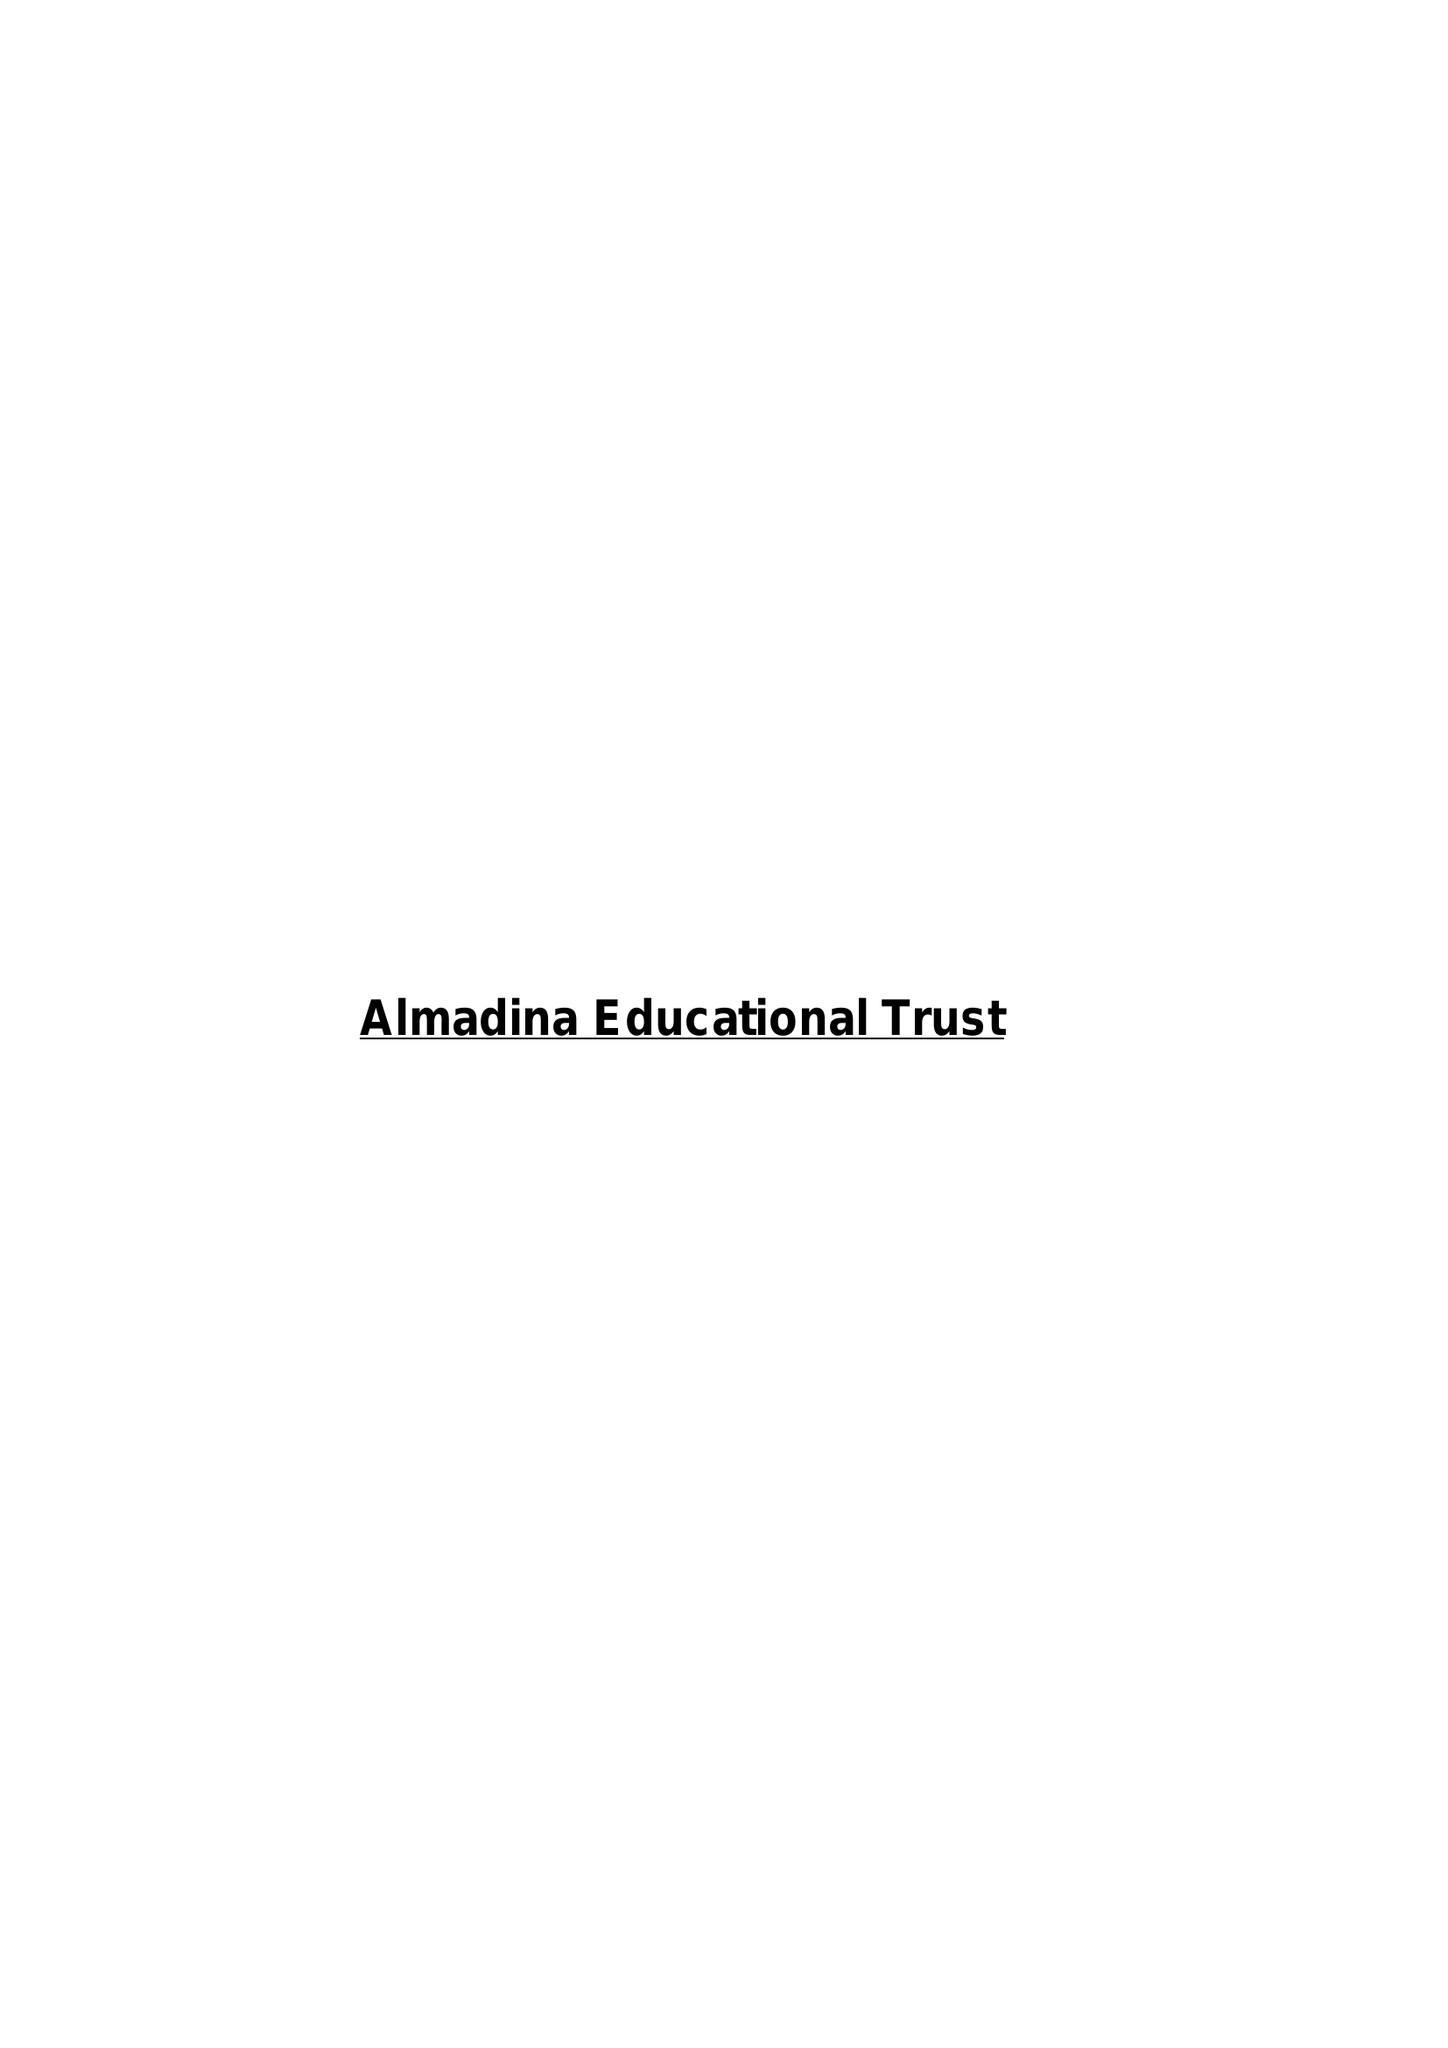What is the value for the spending_annually_in_british_pounds?
Answer the question using a single word or phrase. 47437.00 